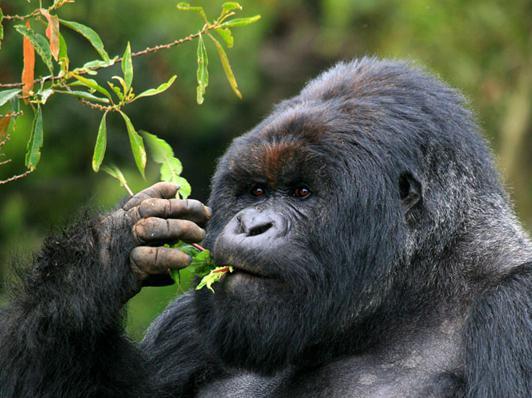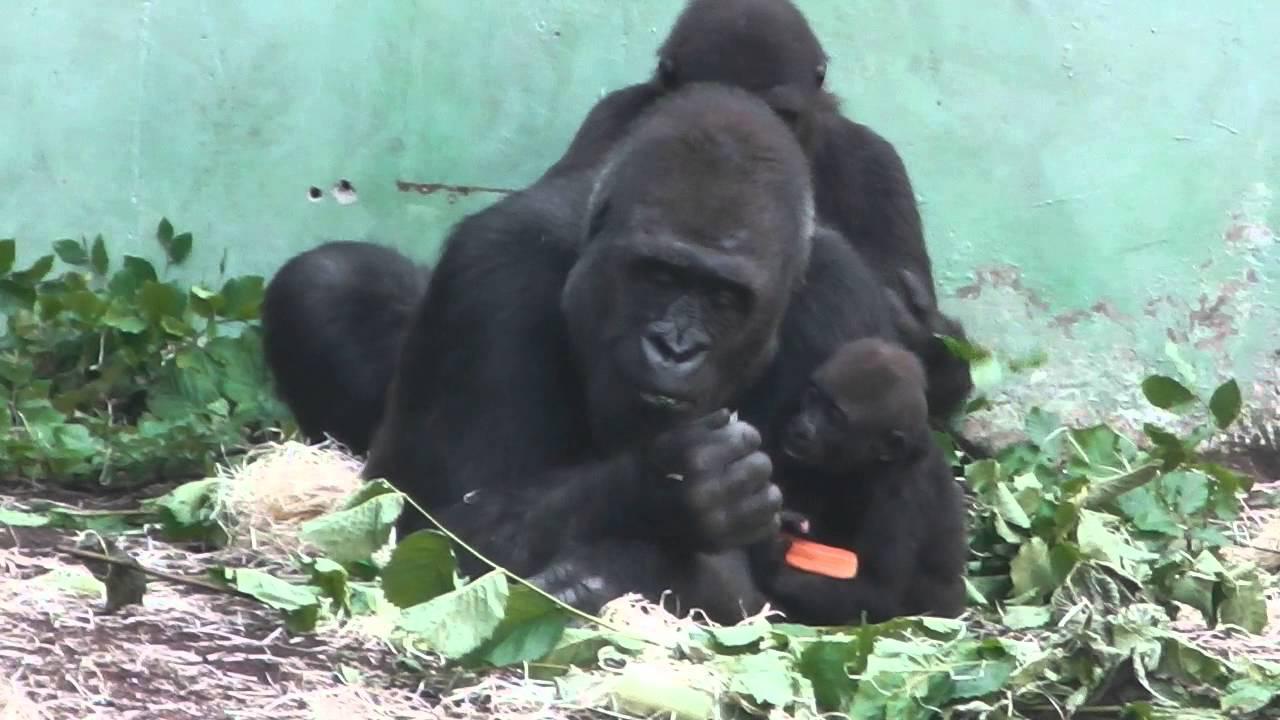The first image is the image on the left, the second image is the image on the right. Assess this claim about the two images: "There are at least two gorillas in the right image.". Correct or not? Answer yes or no. Yes. The first image is the image on the left, the second image is the image on the right. Evaluate the accuracy of this statement regarding the images: "The left image shows a lone gorilla munching foliage, and the right image shows at least one adult gorilla with a baby gorilla.". Is it true? Answer yes or no. Yes. 